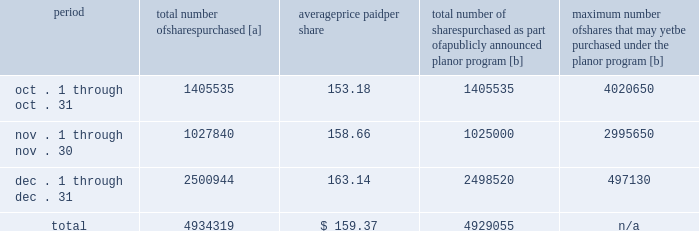Five-year performance comparison 2013 the following graph provides an indicator of cumulative total shareholder returns for the corporation as compared to the peer group index ( described above ) , the dj trans , and the s&p 500 .
The graph assumes that $ 100 was invested in the common stock of union pacific corporation and each index on december 31 , 2008 and that all dividends were reinvested .
The information below is historical in nature and is not necessarily indicative of future performance .
Purchases of equity securities 2013 during 2013 , we repurchased 14996957 shares of our common stock at an average price of $ 152.14 .
The table presents common stock repurchases during each month for the fourth quarter of 2013 : period total number of shares purchased [a] average price paid per share total number of shares purchased as part of a publicly announced plan or program [b] maximum number of shares that may yet be purchased under the plan or program [b] .
[a] total number of shares purchased during the quarter includes approximately 5264 shares delivered or attested to upc by employees to pay stock option exercise prices , satisfy excess tax withholding obligations for stock option exercises or vesting of retention units , and pay withholding obligations for vesting of retention shares .
[b] on april 1 , 2011 , our board of directors authorized the repurchase of up to 40 million shares of our common stock by march 31 , 2014 .
These repurchases may be made on the open market or through other transactions .
Our management has sole discretion with respect to determining the timing and amount of these transactions .
On november 21 , 2013 , the board of directors approved the early renewal of the share repurchase program , authorizing the repurchase of 60 million common shares by december 31 , 2017 .
The new authorization is effective january 1 , 2014 , and replaces the previous authorization , which expired on december 31 , 2013 , three months earlier than its original expiration date. .
What was the percent of the total number of share repurchase in the fourth quarter of 2013 that was attested to upc by employees to pay stock option exercise prices? 
Computations: (5264 / 4934319)
Answer: 0.00107. 